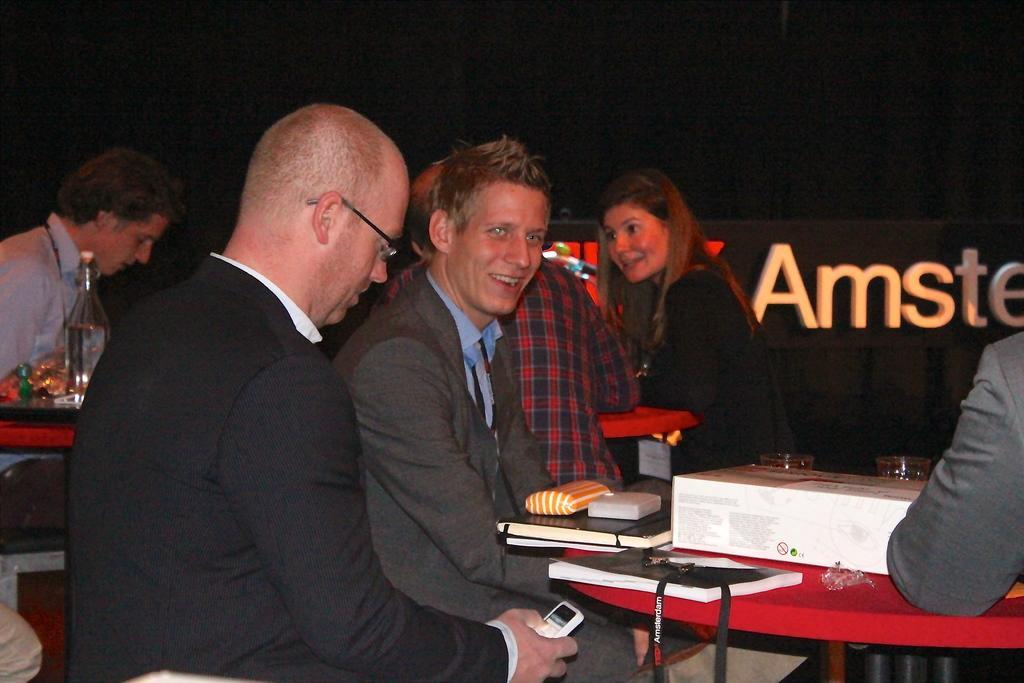Describe this image in one or two sentences. This Image consists of a table and people sitting on stoles near that tables. On the table there are books, files, boxes, bottles, plates. 